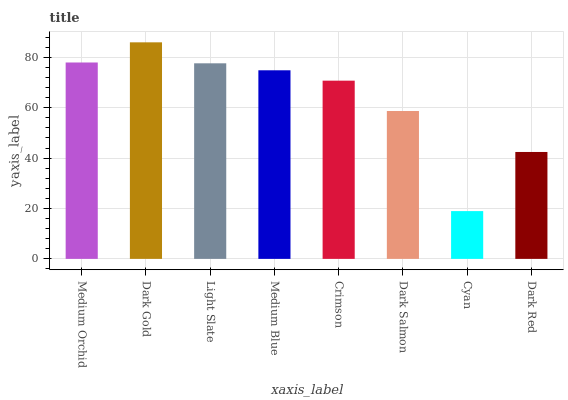Is Cyan the minimum?
Answer yes or no. Yes. Is Dark Gold the maximum?
Answer yes or no. Yes. Is Light Slate the minimum?
Answer yes or no. No. Is Light Slate the maximum?
Answer yes or no. No. Is Dark Gold greater than Light Slate?
Answer yes or no. Yes. Is Light Slate less than Dark Gold?
Answer yes or no. Yes. Is Light Slate greater than Dark Gold?
Answer yes or no. No. Is Dark Gold less than Light Slate?
Answer yes or no. No. Is Medium Blue the high median?
Answer yes or no. Yes. Is Crimson the low median?
Answer yes or no. Yes. Is Light Slate the high median?
Answer yes or no. No. Is Dark Gold the low median?
Answer yes or no. No. 